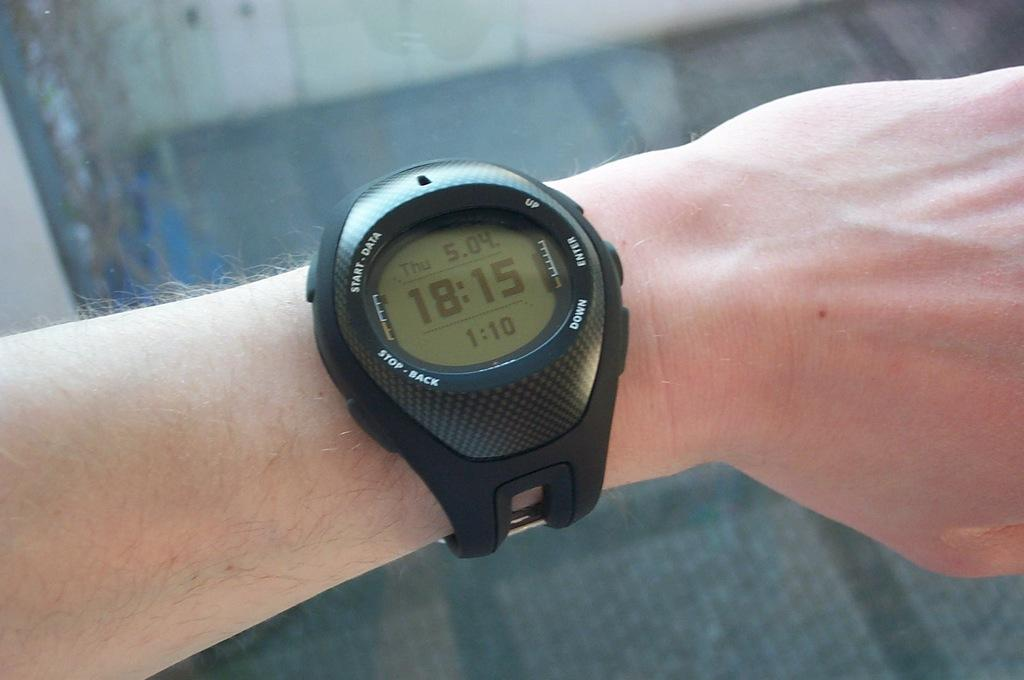Provide a one-sentence caption for the provided image. The watch on the person's left wrist displays a time of 18:15. 